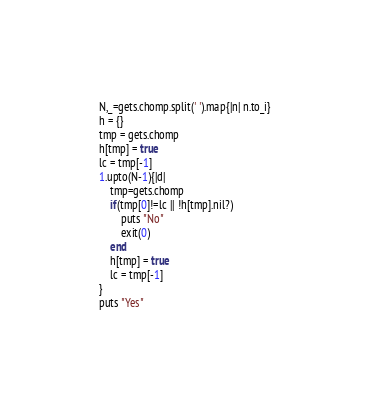Convert code to text. <code><loc_0><loc_0><loc_500><loc_500><_Ruby_>N,_=gets.chomp.split(' ').map{|n| n.to_i}
h = {}
tmp = gets.chomp
h[tmp] = true
lc = tmp[-1]
1.upto(N-1){|d|
	tmp=gets.chomp
	if(tmp[0]!=lc || !h[tmp].nil?)
		puts "No"
		exit(0)
	end
	h[tmp] = true
	lc = tmp[-1]
}
puts "Yes"
</code> 